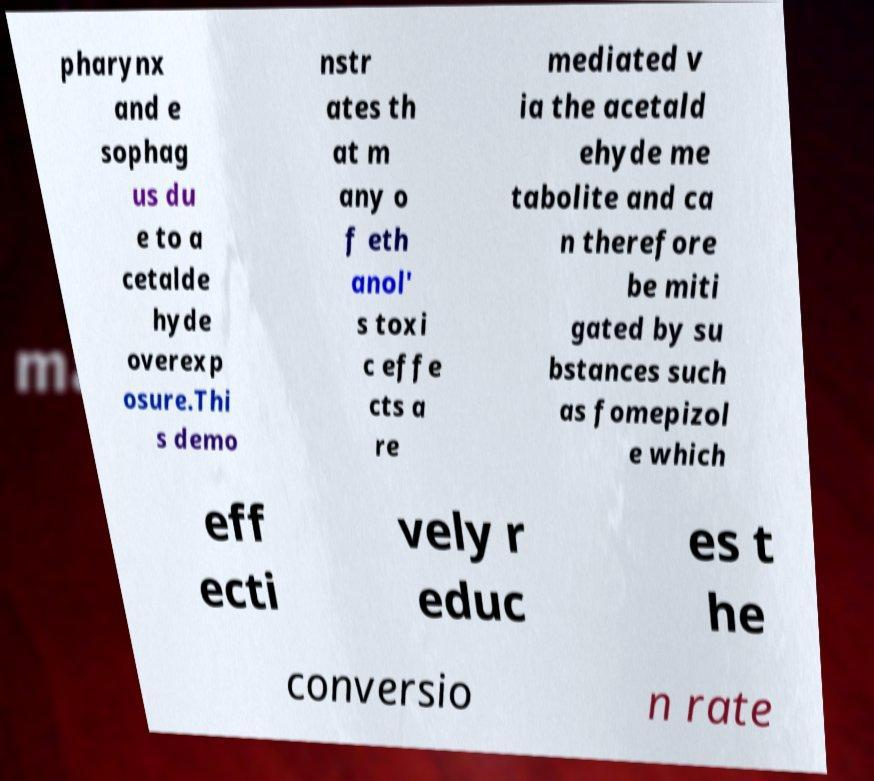Please identify and transcribe the text found in this image. pharynx and e sophag us du e to a cetalde hyde overexp osure.Thi s demo nstr ates th at m any o f eth anol' s toxi c effe cts a re mediated v ia the acetald ehyde me tabolite and ca n therefore be miti gated by su bstances such as fomepizol e which eff ecti vely r educ es t he conversio n rate 